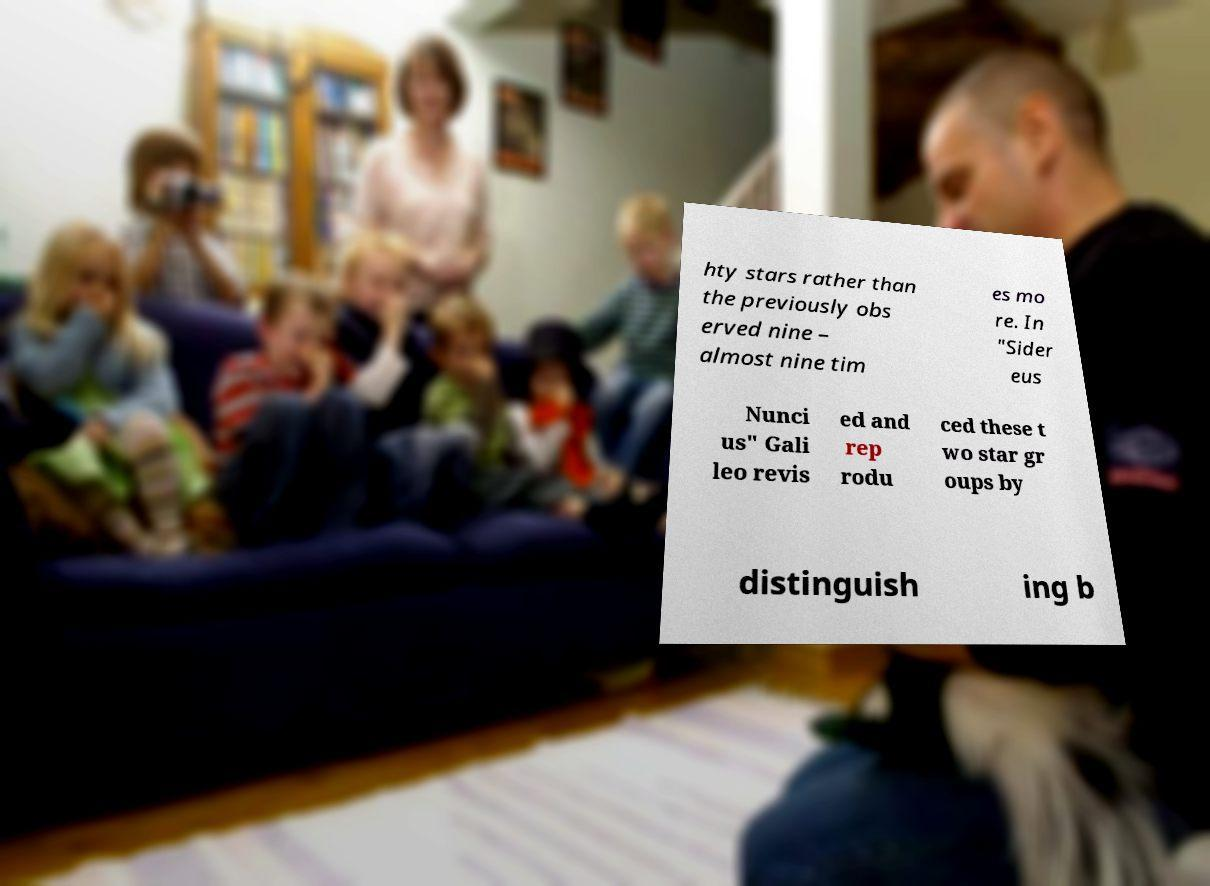Could you assist in decoding the text presented in this image and type it out clearly? hty stars rather than the previously obs erved nine – almost nine tim es mo re. In "Sider eus Nunci us" Gali leo revis ed and rep rodu ced these t wo star gr oups by distinguish ing b 